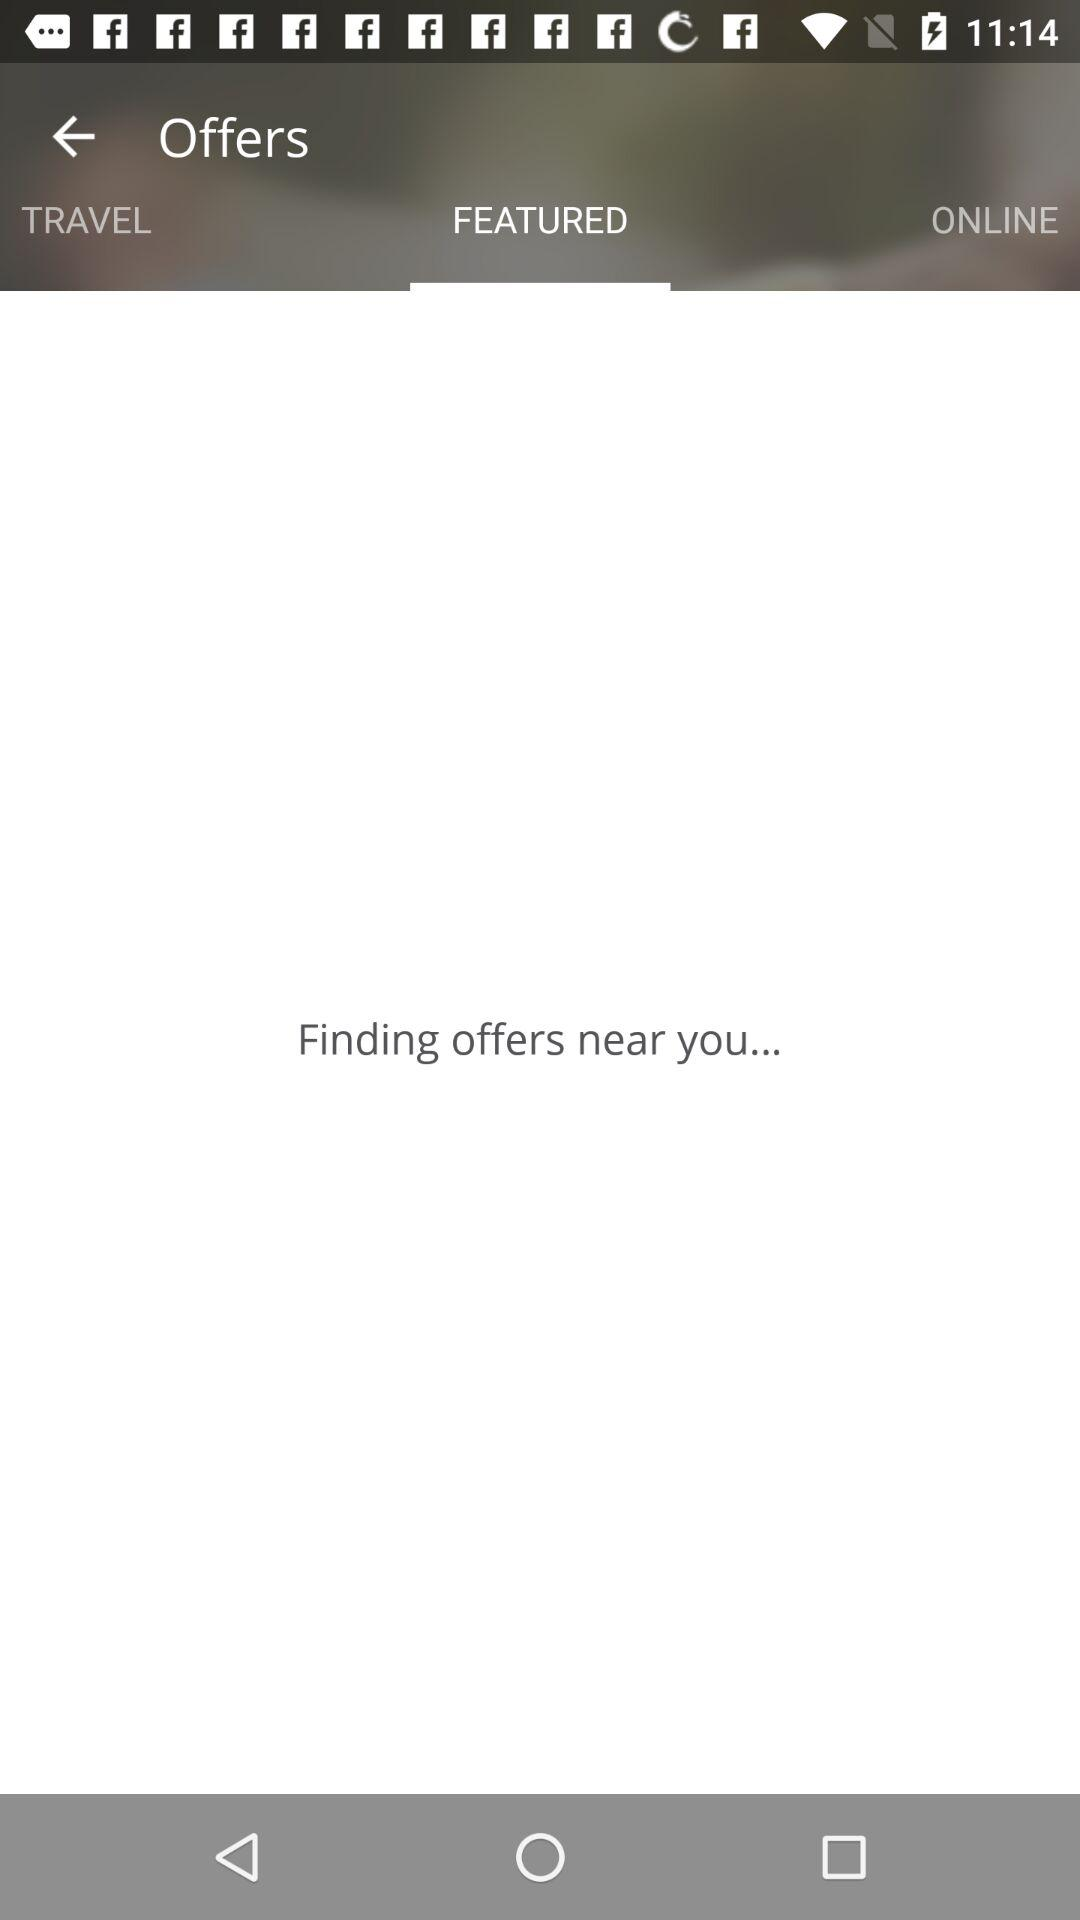Which tab is selected? The selected tab is "FEATURED". 